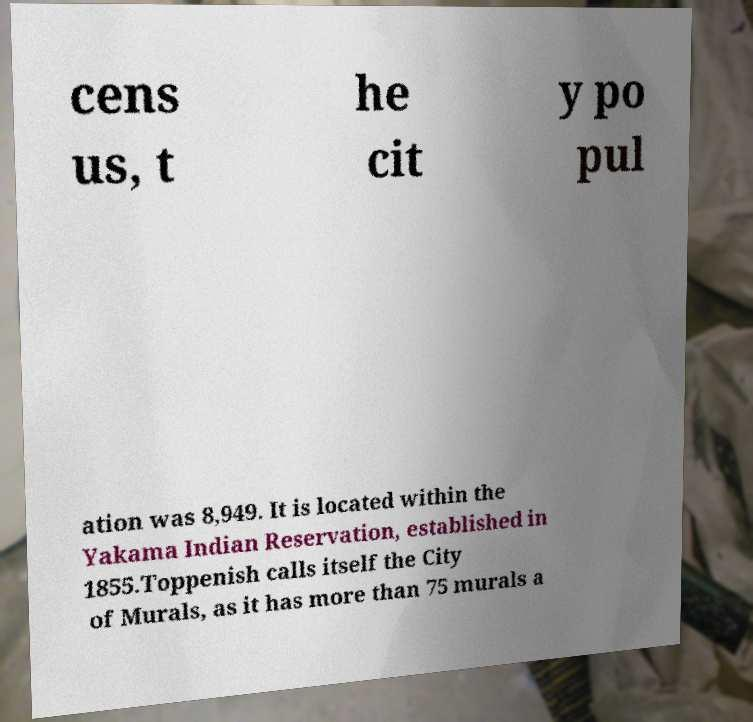I need the written content from this picture converted into text. Can you do that? cens us, t he cit y po pul ation was 8,949. It is located within the Yakama Indian Reservation, established in 1855.Toppenish calls itself the City of Murals, as it has more than 75 murals a 